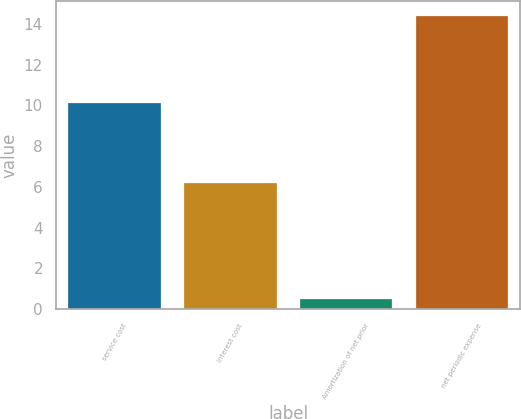Convert chart. <chart><loc_0><loc_0><loc_500><loc_500><bar_chart><fcel>service cost<fcel>interest cost<fcel>Amortization of net prior<fcel>net periodic expense<nl><fcel>10.1<fcel>6.2<fcel>0.5<fcel>14.4<nl></chart> 